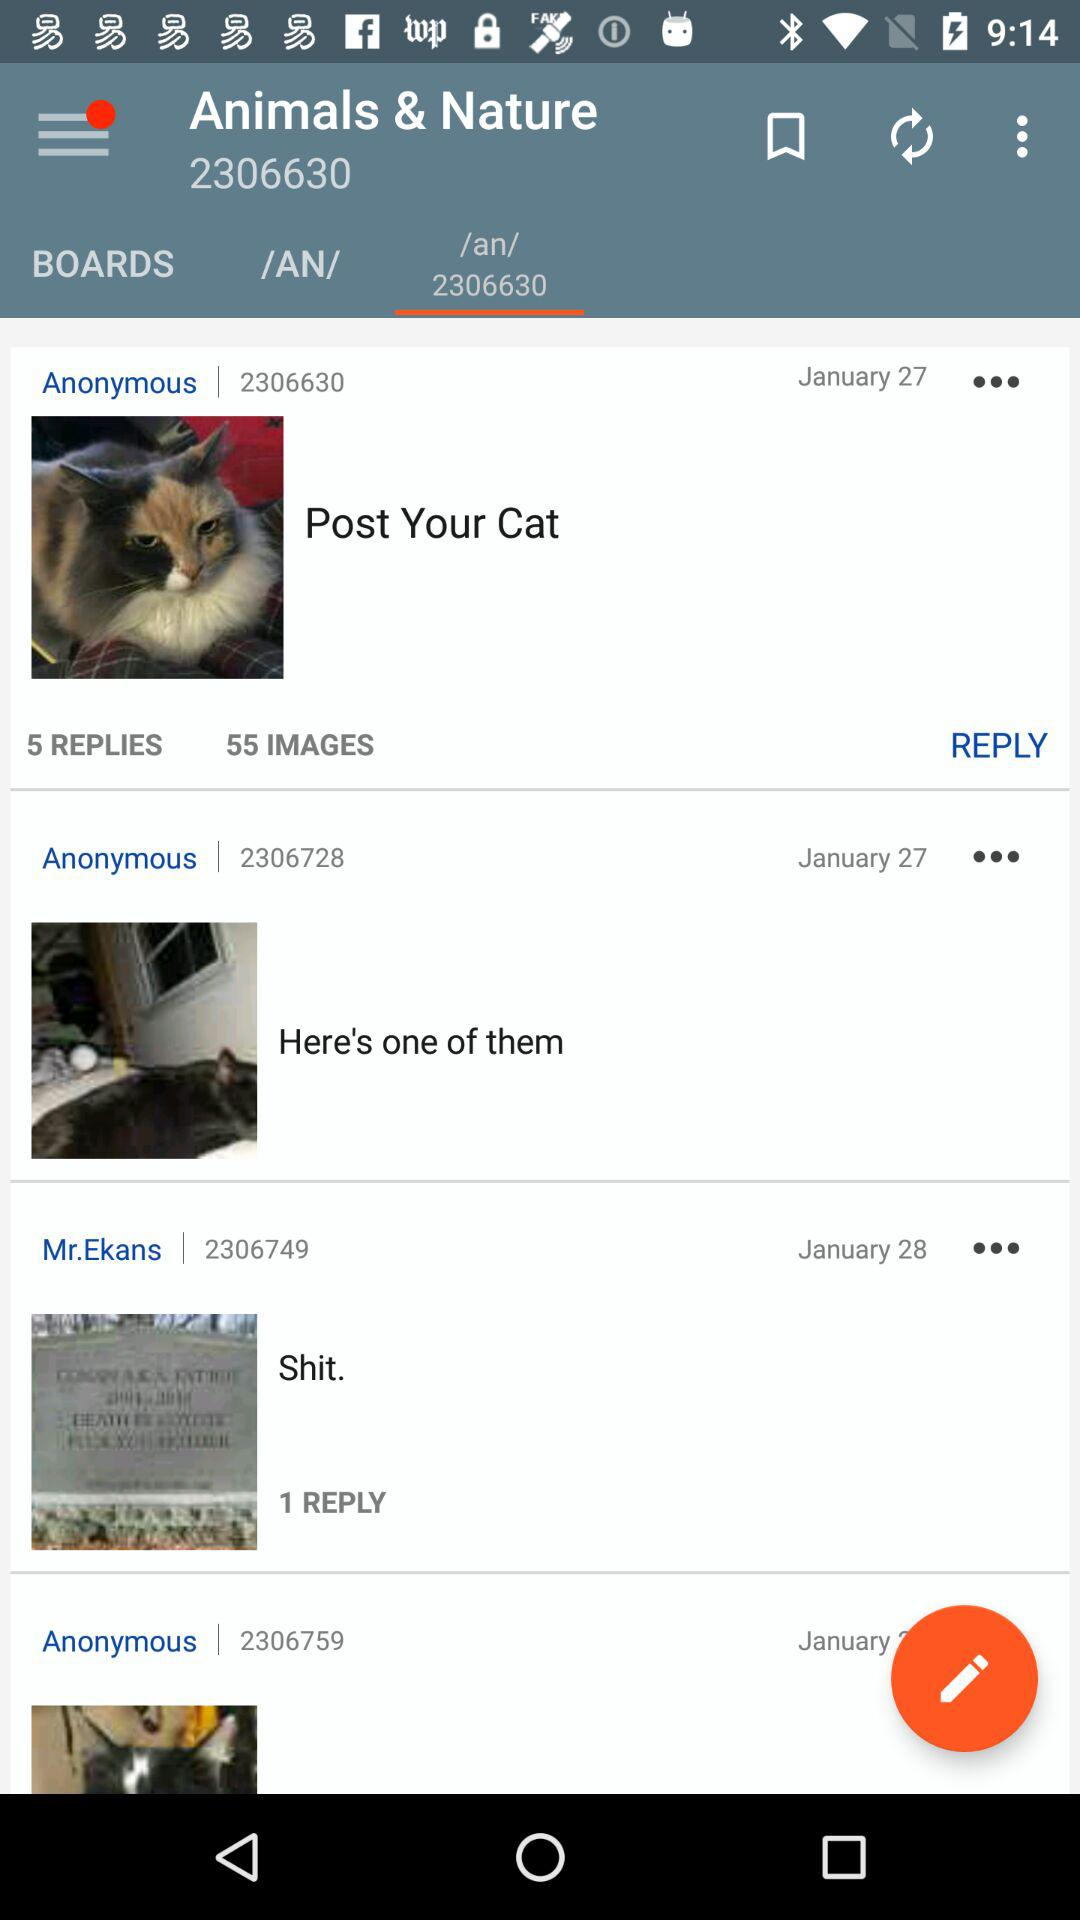How many more replies does the first post have than the second?
Answer the question using a single word or phrase. 4 